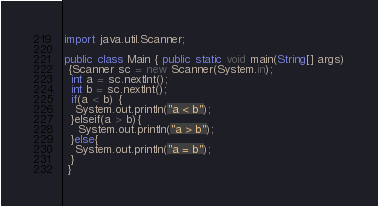<code> <loc_0><loc_0><loc_500><loc_500><_JavaScript_>import java.util.Scanner;

public class Main { public static void main(String[] args)
 {Scanner sc = new Scanner(System.in);
  int a = sc.nextInt();
  int b = sc.nextInt();
  if(a < b) {
   System.out.println("a < b");
  }elseif(a > b){
    System.out.printIn("a > b");
  }else{
   System.out.printIn("a = b");
  }
 }</code> 